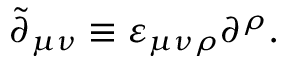<formula> <loc_0><loc_0><loc_500><loc_500>\tilde { \partial } _ { \mu \nu } \equiv \varepsilon _ { \mu \nu \rho } \partial ^ { \rho } .</formula> 